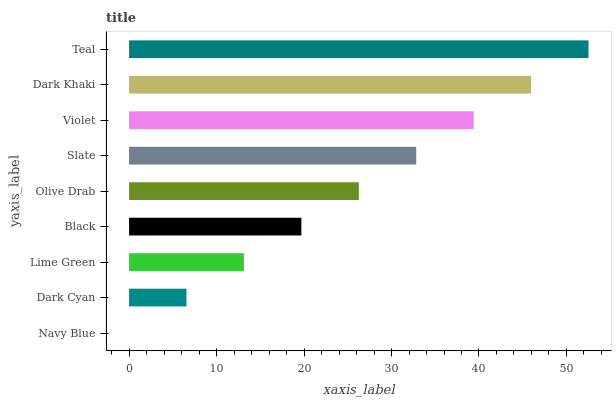Is Navy Blue the minimum?
Answer yes or no. Yes. Is Teal the maximum?
Answer yes or no. Yes. Is Dark Cyan the minimum?
Answer yes or no. No. Is Dark Cyan the maximum?
Answer yes or no. No. Is Dark Cyan greater than Navy Blue?
Answer yes or no. Yes. Is Navy Blue less than Dark Cyan?
Answer yes or no. Yes. Is Navy Blue greater than Dark Cyan?
Answer yes or no. No. Is Dark Cyan less than Navy Blue?
Answer yes or no. No. Is Olive Drab the high median?
Answer yes or no. Yes. Is Olive Drab the low median?
Answer yes or no. Yes. Is Dark Cyan the high median?
Answer yes or no. No. Is Violet the low median?
Answer yes or no. No. 